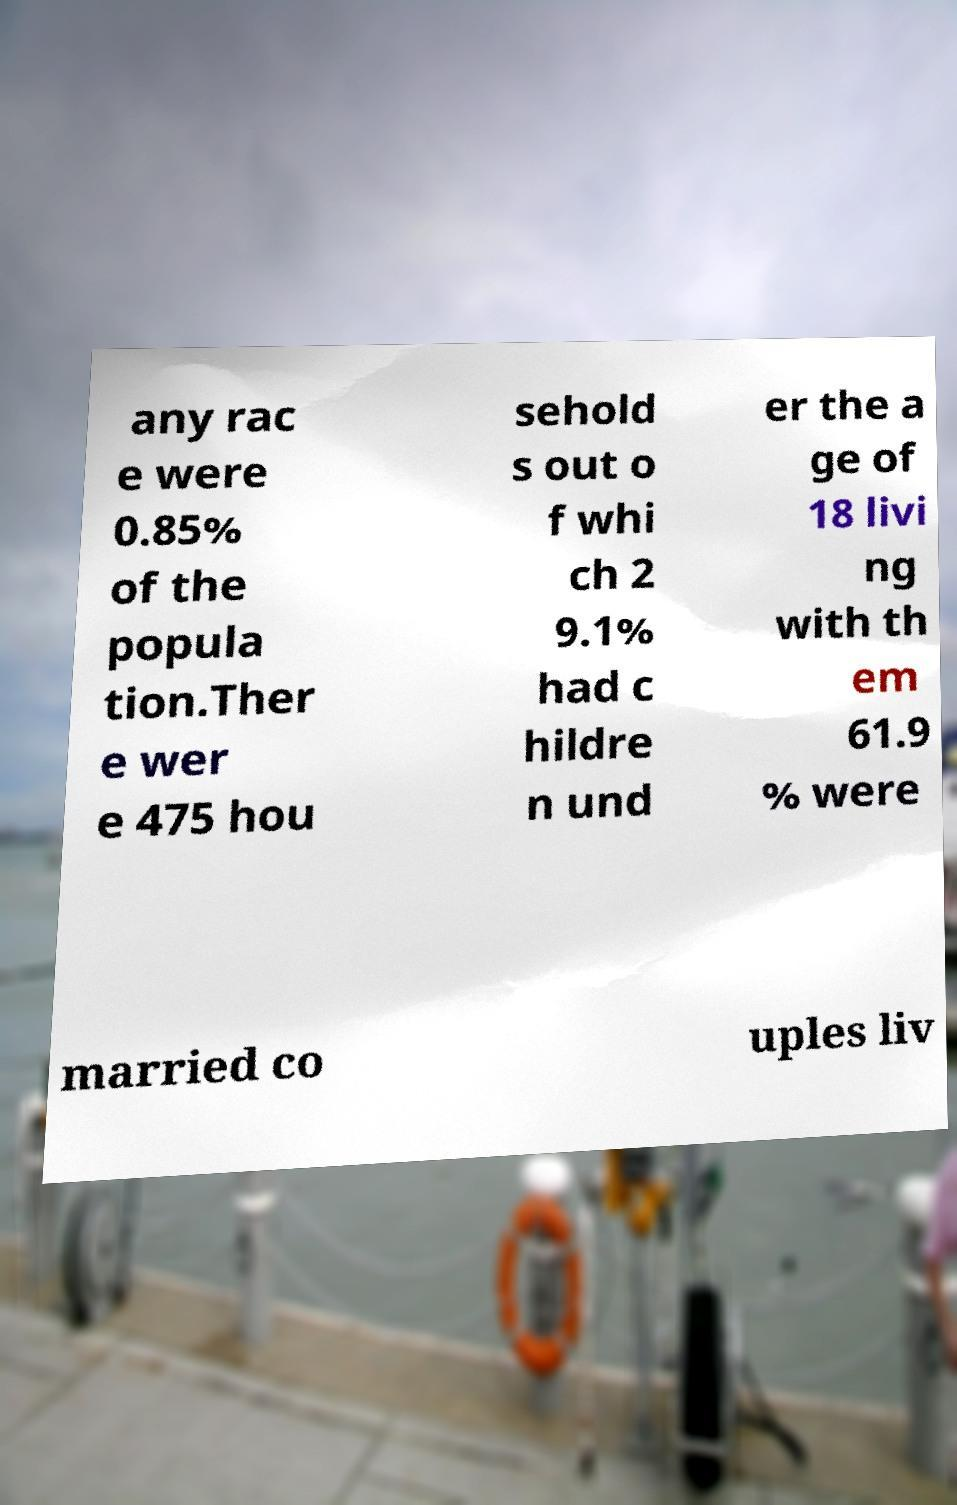I need the written content from this picture converted into text. Can you do that? any rac e were 0.85% of the popula tion.Ther e wer e 475 hou sehold s out o f whi ch 2 9.1% had c hildre n und er the a ge of 18 livi ng with th em 61.9 % were married co uples liv 